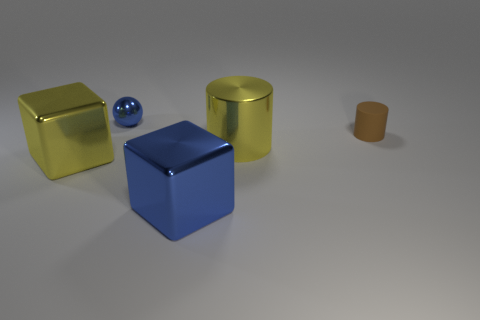Add 2 small green rubber spheres. How many objects exist? 7 Subtract all cubes. How many objects are left? 3 Subtract 0 green cylinders. How many objects are left? 5 Subtract all big cylinders. Subtract all yellow cylinders. How many objects are left? 3 Add 1 tiny spheres. How many tiny spheres are left? 2 Add 1 big green cubes. How many big green cubes exist? 1 